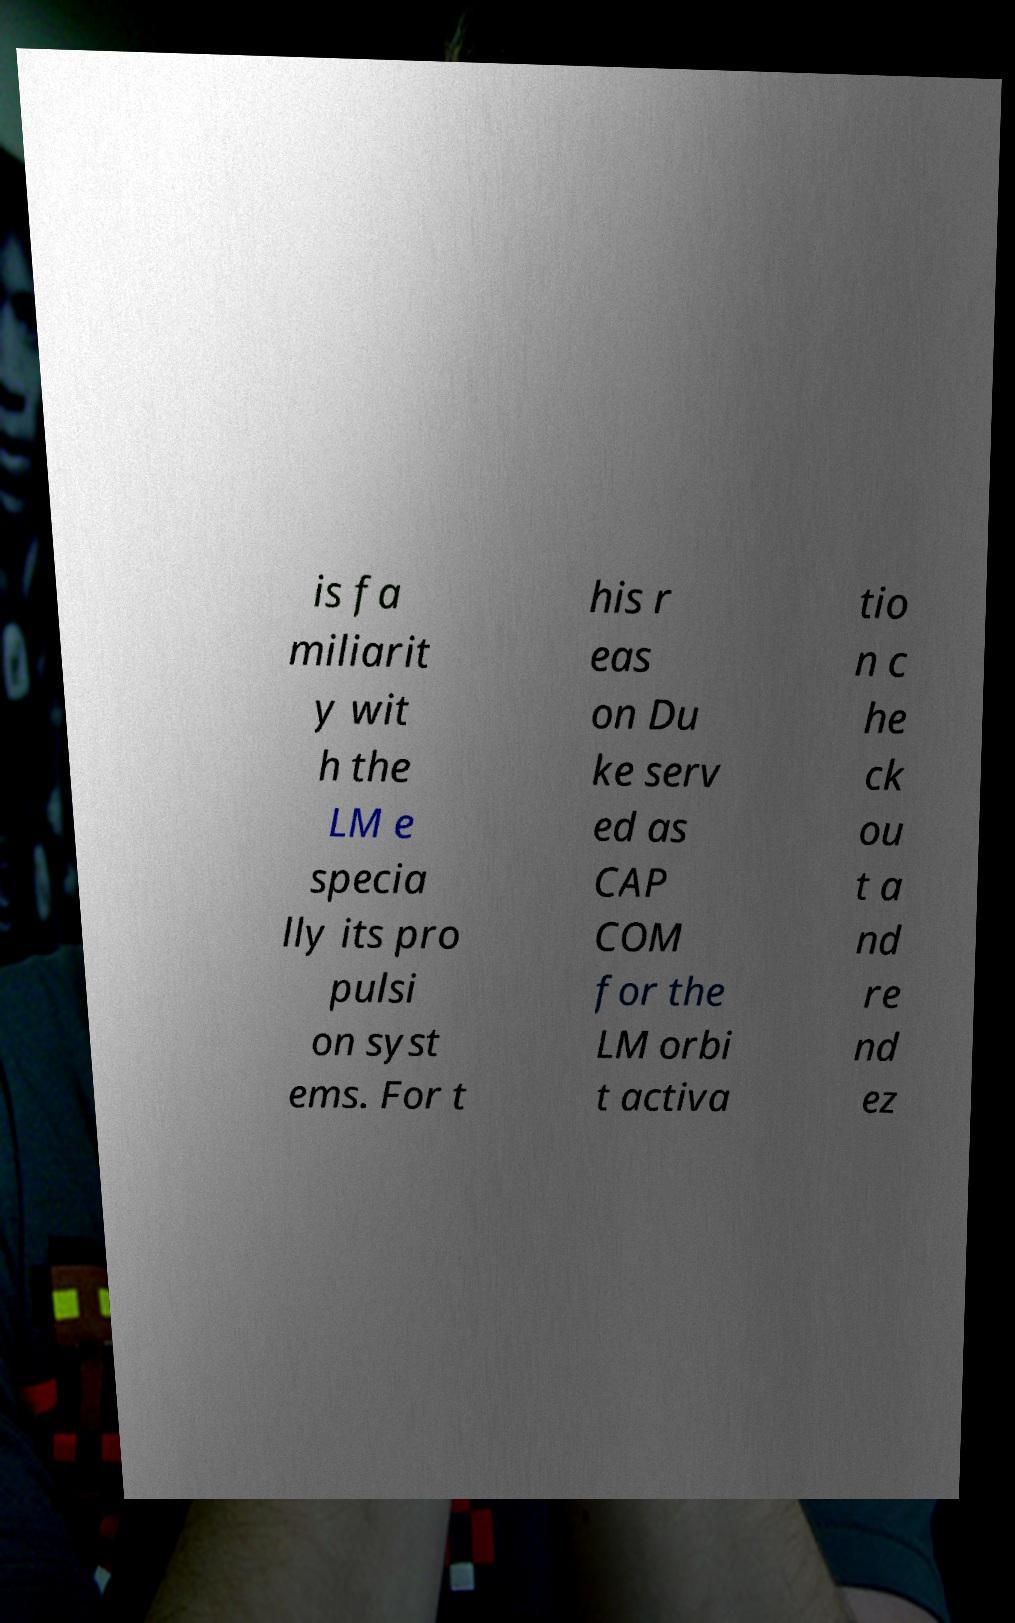What messages or text are displayed in this image? I need them in a readable, typed format. is fa miliarit y wit h the LM e specia lly its pro pulsi on syst ems. For t his r eas on Du ke serv ed as CAP COM for the LM orbi t activa tio n c he ck ou t a nd re nd ez 